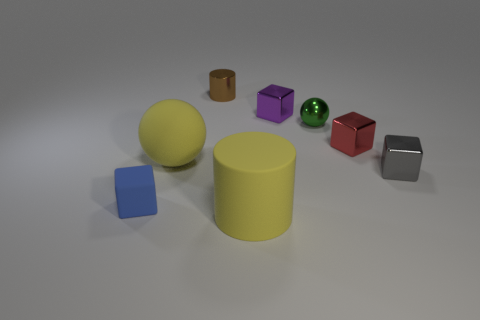What is the color of the shiny cube that is in front of the yellow thing that is left of the cylinder that is in front of the green object?
Keep it short and to the point. Gray. There is a large cylinder that is made of the same material as the small blue thing; what is its color?
Make the answer very short. Yellow. Is there any other thing that is the same size as the green ball?
Make the answer very short. Yes. How many objects are large yellow matte balls that are right of the blue object or small metallic blocks that are in front of the tiny purple thing?
Give a very brief answer. 3. There is a thing in front of the matte block; does it have the same size as the yellow matte thing on the left side of the brown metal cylinder?
Offer a very short reply. Yes. What color is the matte object that is the same shape as the tiny red metallic thing?
Make the answer very short. Blue. Is there anything else that has the same shape as the tiny red shiny thing?
Provide a succinct answer. Yes. Is the number of small red objects that are left of the brown metallic object greater than the number of large balls that are on the right side of the red shiny thing?
Keep it short and to the point. No. There is a matte thing that is behind the blue rubber object that is to the left of the big object on the left side of the brown thing; how big is it?
Offer a terse response. Large. Is the tiny blue thing made of the same material as the cylinder behind the big matte cylinder?
Your response must be concise. No. 